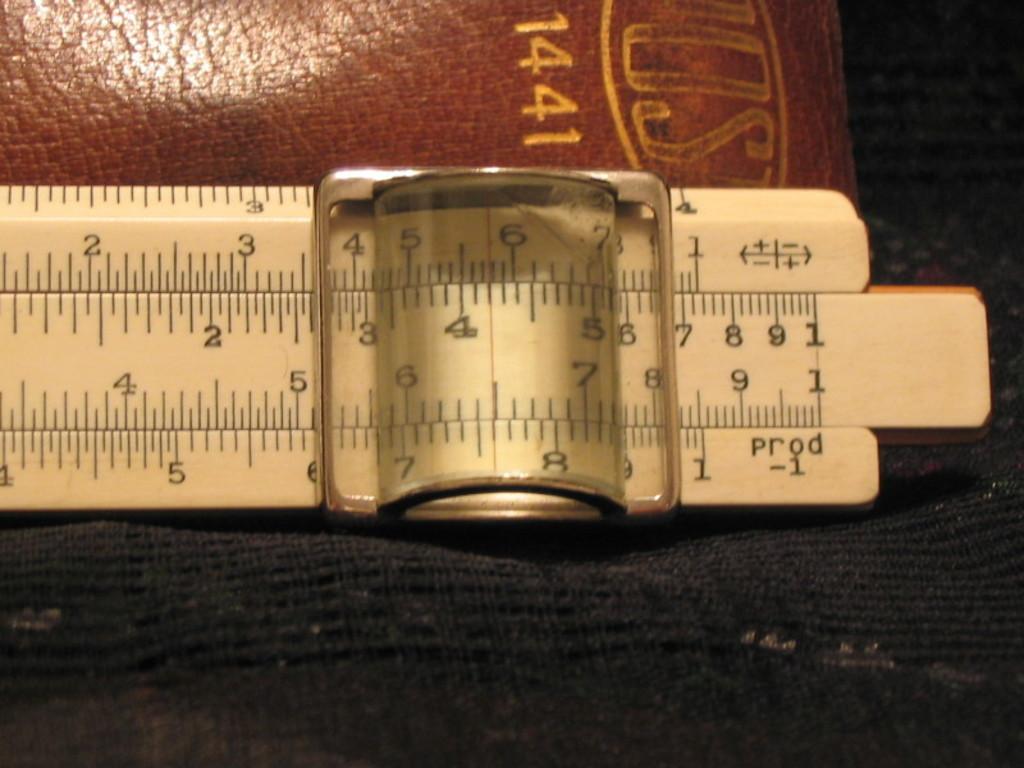What number is on the leather cover?
Offer a terse response. 1441. What is the last number on the ruler?
Your response must be concise. 1. 